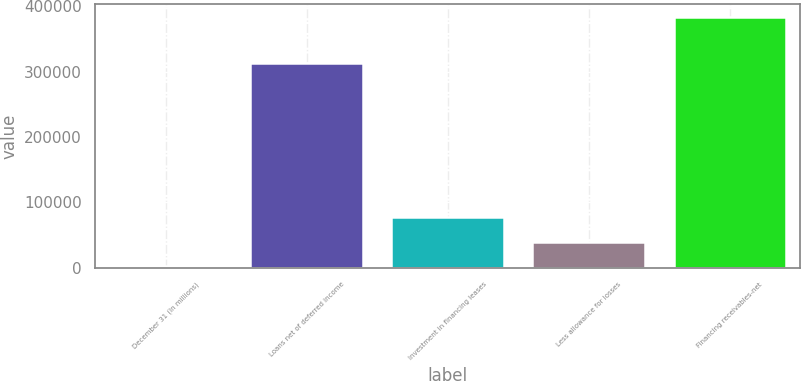Convert chart to OTSL. <chart><loc_0><loc_0><loc_500><loc_500><bar_chart><fcel>December 31 (In millions)<fcel>Loans net of deferred income<fcel>Investment in financing leases<fcel>Less allowance for losses<fcel>Financing receivables-net<nl><fcel>2007<fcel>313290<fcel>78419<fcel>40213<fcel>384067<nl></chart> 